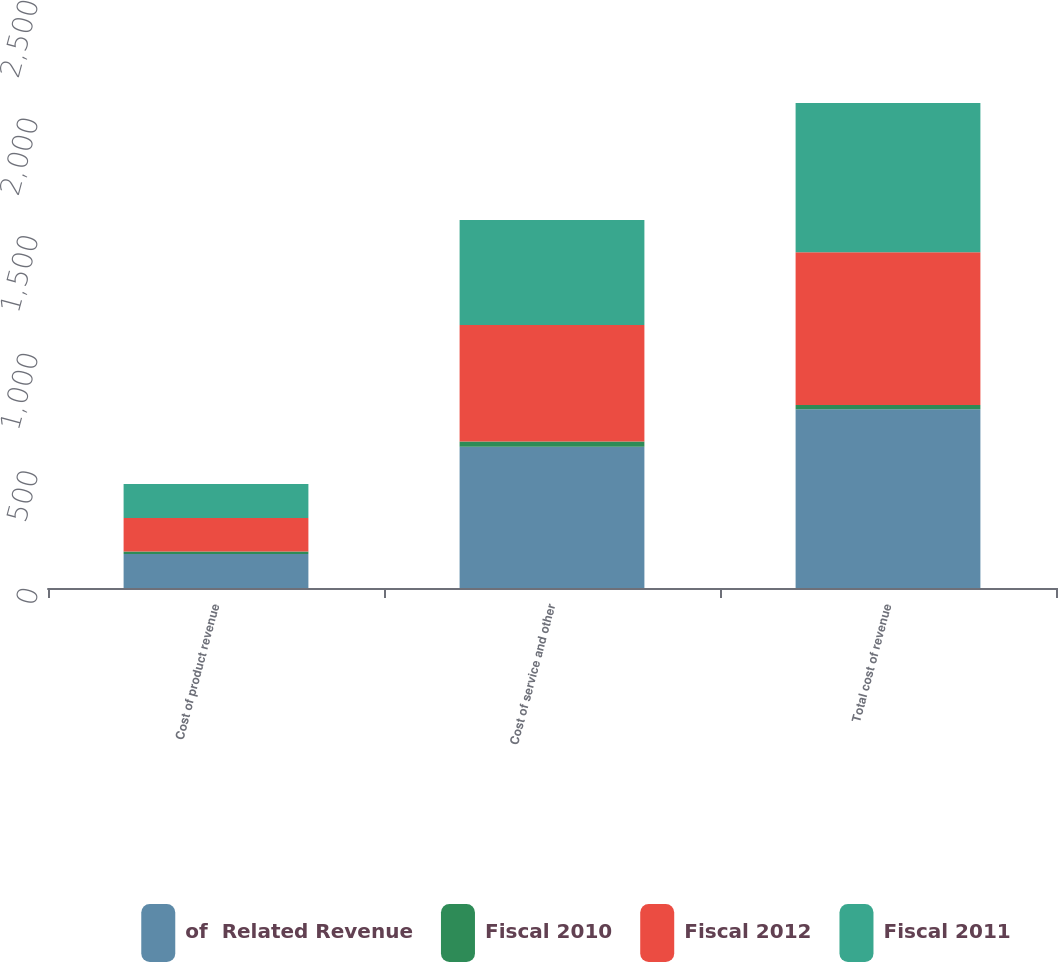Convert chart. <chart><loc_0><loc_0><loc_500><loc_500><stacked_bar_chart><ecel><fcel>Cost of product revenue<fcel>Cost of service and other<fcel>Total cost of revenue<nl><fcel>of  Related Revenue<fcel>145<fcel>601<fcel>760<nl><fcel>Fiscal 2010<fcel>10<fcel>22<fcel>18<nl><fcel>Fiscal 2012<fcel>143<fcel>495<fcel>650<nl><fcel>Fiscal 2011<fcel>144<fcel>447<fcel>634<nl></chart> 